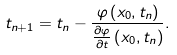<formula> <loc_0><loc_0><loc_500><loc_500>t _ { n + 1 } = t _ { n } - \frac { \varphi \left ( x _ { 0 } , t _ { n } \right ) } { \frac { \partial \varphi } { \partial t } \left ( x _ { 0 } , t _ { n } \right ) } .</formula> 